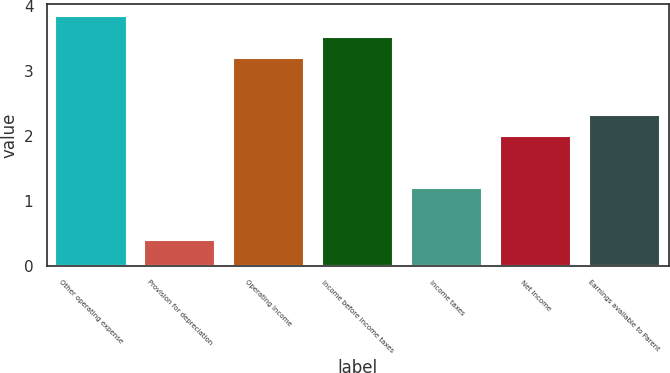<chart> <loc_0><loc_0><loc_500><loc_500><bar_chart><fcel>Other operating expense<fcel>Provision for depreciation<fcel>Operating Income<fcel>Income before income taxes<fcel>Income taxes<fcel>Net Income<fcel>Earnings available to Parent<nl><fcel>3.84<fcel>0.4<fcel>3.2<fcel>3.52<fcel>1.2<fcel>2<fcel>2.32<nl></chart> 